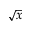Convert formula to latex. <formula><loc_0><loc_0><loc_500><loc_500>\sqrt { x }</formula> 